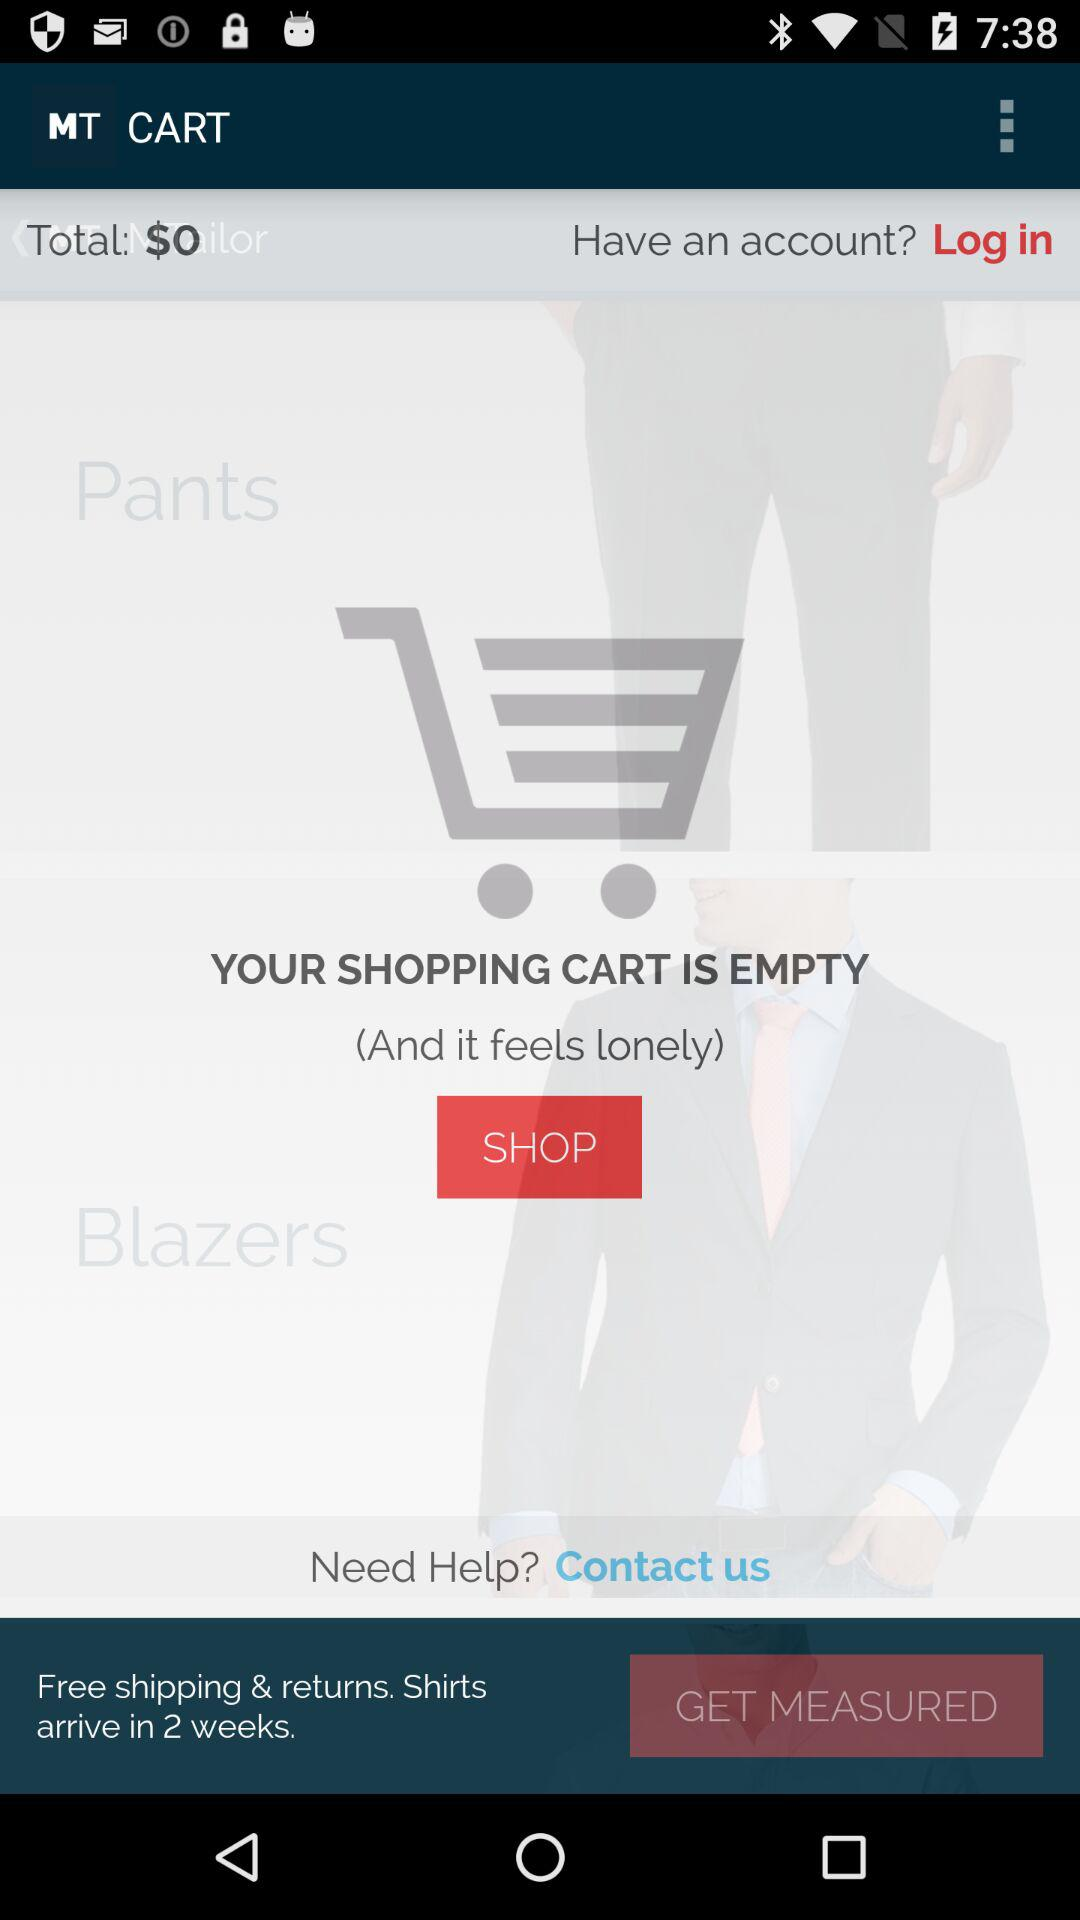How many items are in the shopping cart?
Answer the question using a single word or phrase. 0 